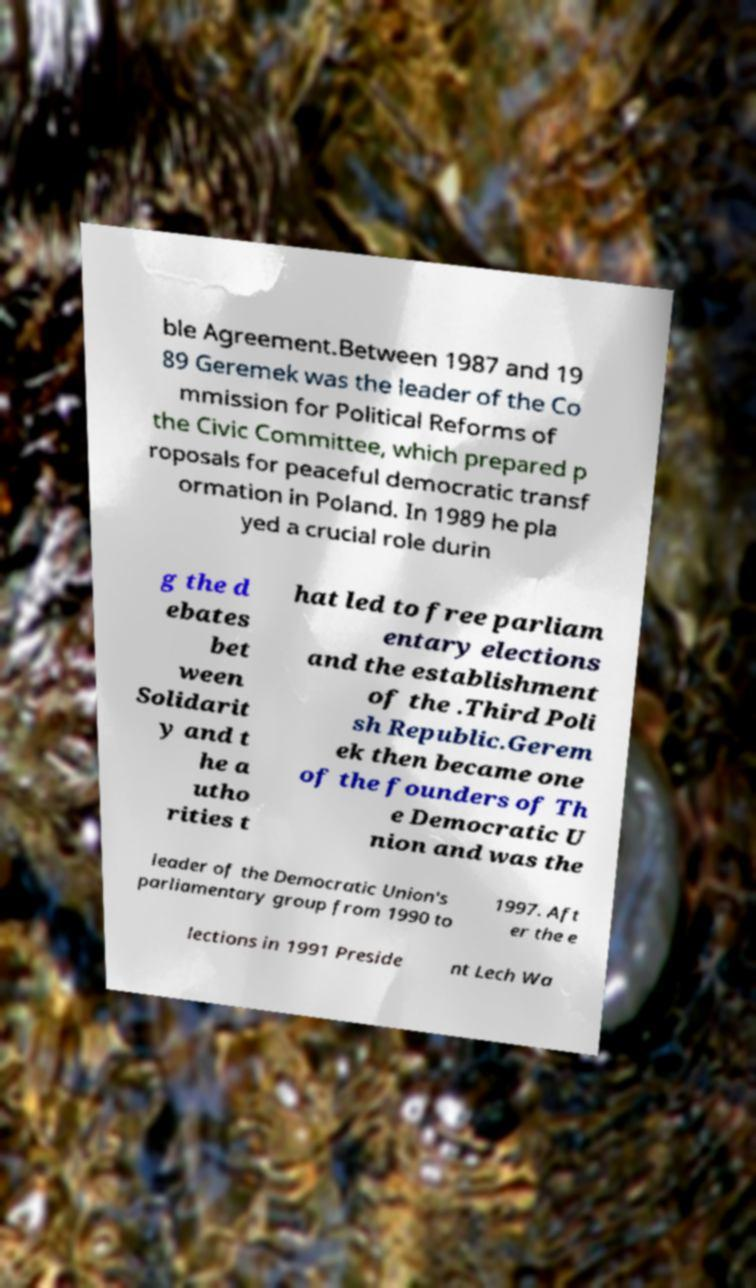What messages or text are displayed in this image? I need them in a readable, typed format. ble Agreement.Between 1987 and 19 89 Geremek was the leader of the Co mmission for Political Reforms of the Civic Committee, which prepared p roposals for peaceful democratic transf ormation in Poland. In 1989 he pla yed a crucial role durin g the d ebates bet ween Solidarit y and t he a utho rities t hat led to free parliam entary elections and the establishment of the .Third Poli sh Republic.Gerem ek then became one of the founders of Th e Democratic U nion and was the leader of the Democratic Union's parliamentary group from 1990 to 1997. Aft er the e lections in 1991 Preside nt Lech Wa 